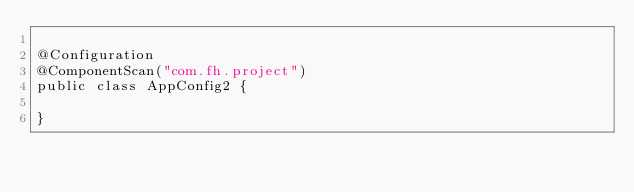<code> <loc_0><loc_0><loc_500><loc_500><_Java_>
@Configuration
@ComponentScan("com.fh.project")
public class AppConfig2 {

}
</code> 